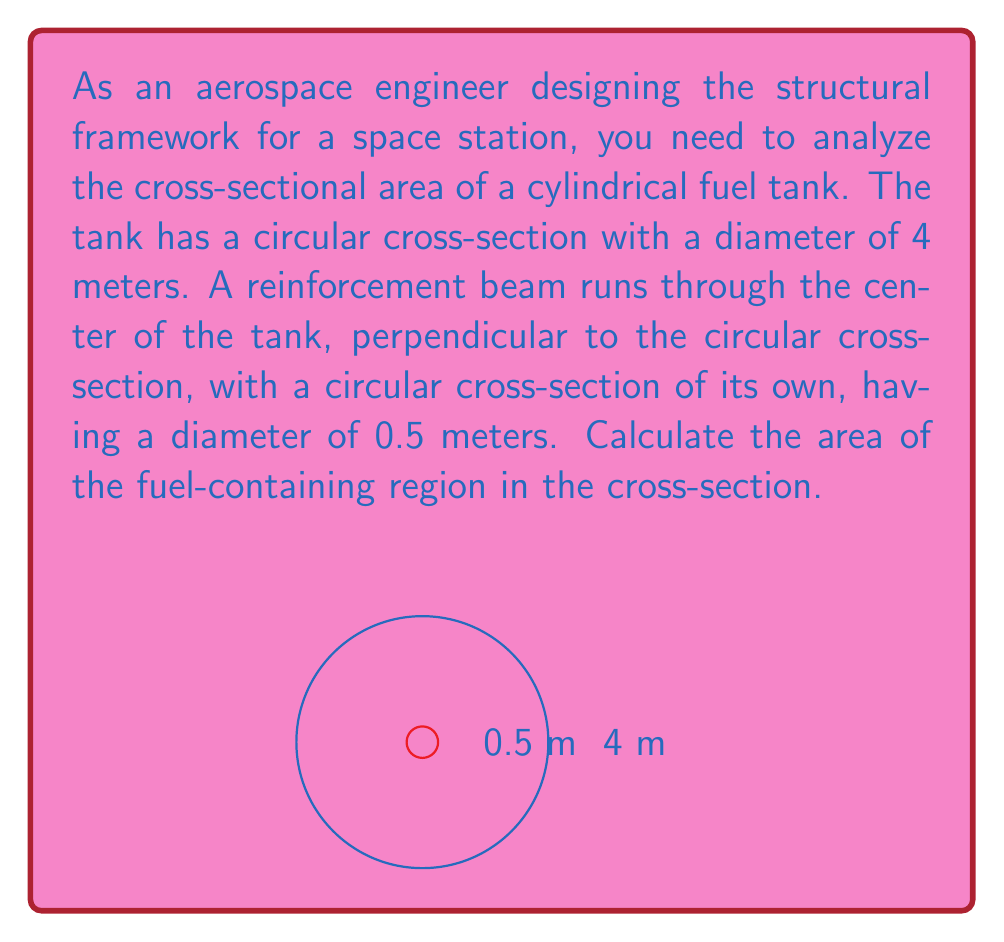Solve this math problem. To solve this problem, we need to follow these steps:

1) First, let's recall the formula for the area of a circle:
   $$A = \pi r^2$$
   where $r$ is the radius of the circle.

2) The fuel tank has a diameter of 4 meters, so its radius is 2 meters. Let's call the area of the larger circle $A_1$:
   $$A_1 = \pi (2)^2 = 4\pi \text{ m}^2$$

3) The reinforcement beam has a diameter of 0.5 meters, so its radius is 0.25 meters. Let's call the area of the smaller circle $A_2$:
   $$A_2 = \pi (0.25)^2 = 0.0625\pi \text{ m}^2$$

4) The fuel-containing region is the area of the larger circle minus the area of the smaller circle:
   $$A_{\text{fuel}} = A_1 - A_2 = 4\pi - 0.0625\pi = 3.9375\pi \text{ m}^2$$

5) Simplifying:
   $$A_{\text{fuel}} = \frac{63}{16}\pi \text{ m}^2 \approx 12.37 \text{ m}^2$$

Therefore, the area of the fuel-containing region in the cross-section is $\frac{63}{16}\pi$ square meters or approximately 12.37 square meters.
Answer: $\frac{63}{16}\pi \text{ m}^2$ or $12.37 \text{ m}^2$ 